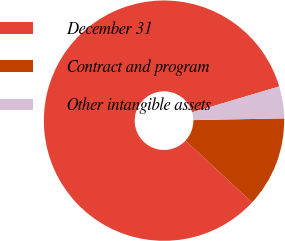<chart> <loc_0><loc_0><loc_500><loc_500><pie_chart><fcel>December 31<fcel>Contract and program<fcel>Other intangible assets<nl><fcel>83.49%<fcel>12.21%<fcel>4.29%<nl></chart> 